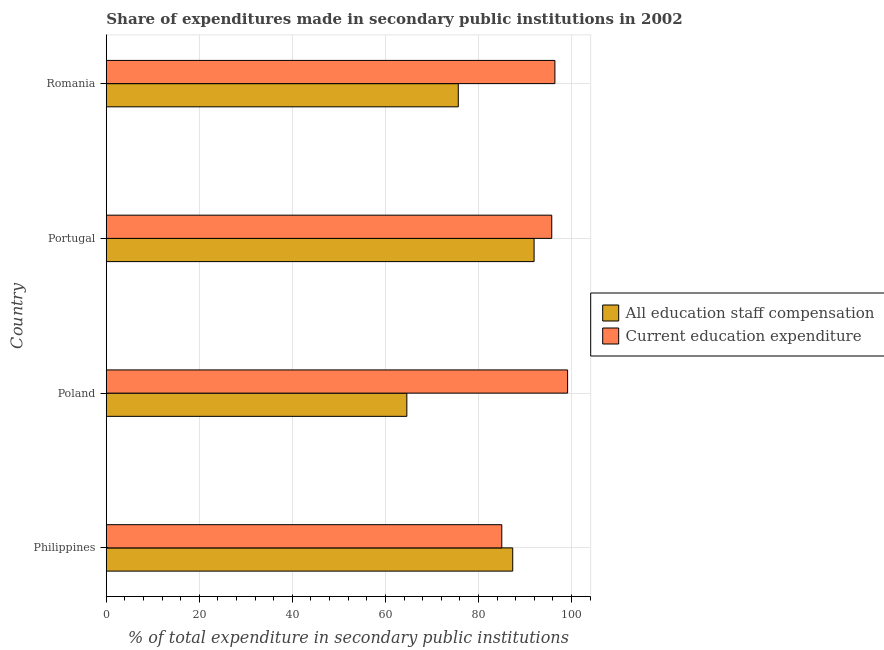How many different coloured bars are there?
Your response must be concise. 2. How many groups of bars are there?
Offer a terse response. 4. Are the number of bars per tick equal to the number of legend labels?
Make the answer very short. Yes. Are the number of bars on each tick of the Y-axis equal?
Make the answer very short. Yes. What is the label of the 2nd group of bars from the top?
Offer a very short reply. Portugal. What is the expenditure in education in Portugal?
Give a very brief answer. 95.76. Across all countries, what is the maximum expenditure in education?
Offer a terse response. 99.17. Across all countries, what is the minimum expenditure in education?
Provide a short and direct response. 85.02. In which country was the expenditure in education minimum?
Your answer should be compact. Philippines. What is the total expenditure in staff compensation in the graph?
Provide a short and direct response. 319.61. What is the difference between the expenditure in staff compensation in Philippines and that in Portugal?
Your answer should be compact. -4.59. What is the difference between the expenditure in staff compensation in Romania and the expenditure in education in Poland?
Make the answer very short. -23.51. What is the average expenditure in education per country?
Ensure brevity in your answer.  94.1. What is the difference between the expenditure in education and expenditure in staff compensation in Portugal?
Offer a very short reply. 3.79. In how many countries, is the expenditure in staff compensation greater than 84 %?
Ensure brevity in your answer.  2. What is the ratio of the expenditure in staff compensation in Philippines to that in Romania?
Your response must be concise. 1.16. What is the difference between the highest and the second highest expenditure in education?
Offer a very short reply. 2.73. What is the difference between the highest and the lowest expenditure in staff compensation?
Offer a terse response. 27.36. What does the 1st bar from the top in Philippines represents?
Ensure brevity in your answer.  Current education expenditure. What does the 1st bar from the bottom in Poland represents?
Offer a terse response. All education staff compensation. Are all the bars in the graph horizontal?
Make the answer very short. Yes. How many countries are there in the graph?
Keep it short and to the point. 4. What is the title of the graph?
Offer a very short reply. Share of expenditures made in secondary public institutions in 2002. What is the label or title of the X-axis?
Offer a very short reply. % of total expenditure in secondary public institutions. What is the % of total expenditure in secondary public institutions in All education staff compensation in Philippines?
Your answer should be very brief. 87.37. What is the % of total expenditure in secondary public institutions in Current education expenditure in Philippines?
Offer a very short reply. 85.02. What is the % of total expenditure in secondary public institutions of All education staff compensation in Poland?
Your answer should be very brief. 64.61. What is the % of total expenditure in secondary public institutions of Current education expenditure in Poland?
Keep it short and to the point. 99.17. What is the % of total expenditure in secondary public institutions of All education staff compensation in Portugal?
Provide a succinct answer. 91.97. What is the % of total expenditure in secondary public institutions of Current education expenditure in Portugal?
Provide a succinct answer. 95.76. What is the % of total expenditure in secondary public institutions in All education staff compensation in Romania?
Keep it short and to the point. 75.67. What is the % of total expenditure in secondary public institutions in Current education expenditure in Romania?
Your answer should be compact. 96.44. Across all countries, what is the maximum % of total expenditure in secondary public institutions of All education staff compensation?
Keep it short and to the point. 91.97. Across all countries, what is the maximum % of total expenditure in secondary public institutions of Current education expenditure?
Provide a short and direct response. 99.17. Across all countries, what is the minimum % of total expenditure in secondary public institutions of All education staff compensation?
Offer a very short reply. 64.61. Across all countries, what is the minimum % of total expenditure in secondary public institutions in Current education expenditure?
Make the answer very short. 85.02. What is the total % of total expenditure in secondary public institutions in All education staff compensation in the graph?
Offer a terse response. 319.61. What is the total % of total expenditure in secondary public institutions of Current education expenditure in the graph?
Provide a succinct answer. 376.39. What is the difference between the % of total expenditure in secondary public institutions of All education staff compensation in Philippines and that in Poland?
Keep it short and to the point. 22.77. What is the difference between the % of total expenditure in secondary public institutions in Current education expenditure in Philippines and that in Poland?
Make the answer very short. -14.15. What is the difference between the % of total expenditure in secondary public institutions of All education staff compensation in Philippines and that in Portugal?
Give a very brief answer. -4.59. What is the difference between the % of total expenditure in secondary public institutions in Current education expenditure in Philippines and that in Portugal?
Your response must be concise. -10.74. What is the difference between the % of total expenditure in secondary public institutions in All education staff compensation in Philippines and that in Romania?
Your response must be concise. 11.71. What is the difference between the % of total expenditure in secondary public institutions in Current education expenditure in Philippines and that in Romania?
Your response must be concise. -11.42. What is the difference between the % of total expenditure in secondary public institutions of All education staff compensation in Poland and that in Portugal?
Give a very brief answer. -27.36. What is the difference between the % of total expenditure in secondary public institutions of Current education expenditure in Poland and that in Portugal?
Give a very brief answer. 3.41. What is the difference between the % of total expenditure in secondary public institutions in All education staff compensation in Poland and that in Romania?
Provide a succinct answer. -11.06. What is the difference between the % of total expenditure in secondary public institutions of Current education expenditure in Poland and that in Romania?
Make the answer very short. 2.73. What is the difference between the % of total expenditure in secondary public institutions of All education staff compensation in Portugal and that in Romania?
Keep it short and to the point. 16.3. What is the difference between the % of total expenditure in secondary public institutions of Current education expenditure in Portugal and that in Romania?
Your response must be concise. -0.68. What is the difference between the % of total expenditure in secondary public institutions in All education staff compensation in Philippines and the % of total expenditure in secondary public institutions in Current education expenditure in Poland?
Your answer should be very brief. -11.8. What is the difference between the % of total expenditure in secondary public institutions of All education staff compensation in Philippines and the % of total expenditure in secondary public institutions of Current education expenditure in Portugal?
Offer a very short reply. -8.39. What is the difference between the % of total expenditure in secondary public institutions in All education staff compensation in Philippines and the % of total expenditure in secondary public institutions in Current education expenditure in Romania?
Provide a short and direct response. -9.06. What is the difference between the % of total expenditure in secondary public institutions of All education staff compensation in Poland and the % of total expenditure in secondary public institutions of Current education expenditure in Portugal?
Offer a terse response. -31.15. What is the difference between the % of total expenditure in secondary public institutions in All education staff compensation in Poland and the % of total expenditure in secondary public institutions in Current education expenditure in Romania?
Provide a short and direct response. -31.83. What is the difference between the % of total expenditure in secondary public institutions of All education staff compensation in Portugal and the % of total expenditure in secondary public institutions of Current education expenditure in Romania?
Ensure brevity in your answer.  -4.47. What is the average % of total expenditure in secondary public institutions in All education staff compensation per country?
Your response must be concise. 79.9. What is the average % of total expenditure in secondary public institutions in Current education expenditure per country?
Make the answer very short. 94.1. What is the difference between the % of total expenditure in secondary public institutions of All education staff compensation and % of total expenditure in secondary public institutions of Current education expenditure in Philippines?
Offer a terse response. 2.35. What is the difference between the % of total expenditure in secondary public institutions in All education staff compensation and % of total expenditure in secondary public institutions in Current education expenditure in Poland?
Your answer should be very brief. -34.56. What is the difference between the % of total expenditure in secondary public institutions of All education staff compensation and % of total expenditure in secondary public institutions of Current education expenditure in Portugal?
Offer a terse response. -3.79. What is the difference between the % of total expenditure in secondary public institutions of All education staff compensation and % of total expenditure in secondary public institutions of Current education expenditure in Romania?
Ensure brevity in your answer.  -20.77. What is the ratio of the % of total expenditure in secondary public institutions in All education staff compensation in Philippines to that in Poland?
Make the answer very short. 1.35. What is the ratio of the % of total expenditure in secondary public institutions of Current education expenditure in Philippines to that in Poland?
Offer a very short reply. 0.86. What is the ratio of the % of total expenditure in secondary public institutions of All education staff compensation in Philippines to that in Portugal?
Make the answer very short. 0.95. What is the ratio of the % of total expenditure in secondary public institutions of Current education expenditure in Philippines to that in Portugal?
Provide a succinct answer. 0.89. What is the ratio of the % of total expenditure in secondary public institutions in All education staff compensation in Philippines to that in Romania?
Give a very brief answer. 1.15. What is the ratio of the % of total expenditure in secondary public institutions of Current education expenditure in Philippines to that in Romania?
Offer a terse response. 0.88. What is the ratio of the % of total expenditure in secondary public institutions of All education staff compensation in Poland to that in Portugal?
Offer a very short reply. 0.7. What is the ratio of the % of total expenditure in secondary public institutions in Current education expenditure in Poland to that in Portugal?
Ensure brevity in your answer.  1.04. What is the ratio of the % of total expenditure in secondary public institutions of All education staff compensation in Poland to that in Romania?
Your answer should be compact. 0.85. What is the ratio of the % of total expenditure in secondary public institutions of Current education expenditure in Poland to that in Romania?
Keep it short and to the point. 1.03. What is the ratio of the % of total expenditure in secondary public institutions in All education staff compensation in Portugal to that in Romania?
Keep it short and to the point. 1.22. What is the ratio of the % of total expenditure in secondary public institutions of Current education expenditure in Portugal to that in Romania?
Make the answer very short. 0.99. What is the difference between the highest and the second highest % of total expenditure in secondary public institutions of All education staff compensation?
Keep it short and to the point. 4.59. What is the difference between the highest and the second highest % of total expenditure in secondary public institutions of Current education expenditure?
Provide a short and direct response. 2.73. What is the difference between the highest and the lowest % of total expenditure in secondary public institutions of All education staff compensation?
Offer a very short reply. 27.36. What is the difference between the highest and the lowest % of total expenditure in secondary public institutions of Current education expenditure?
Provide a short and direct response. 14.15. 